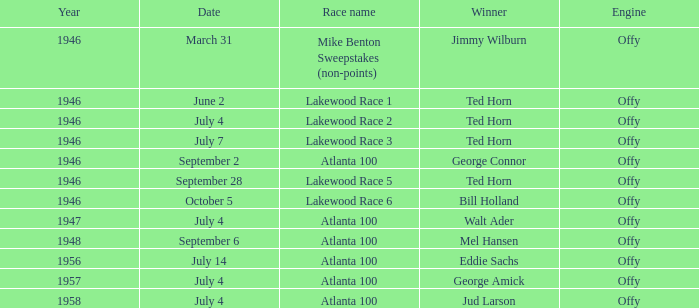Jud larson won which competition following 1956? Atlanta 100. 